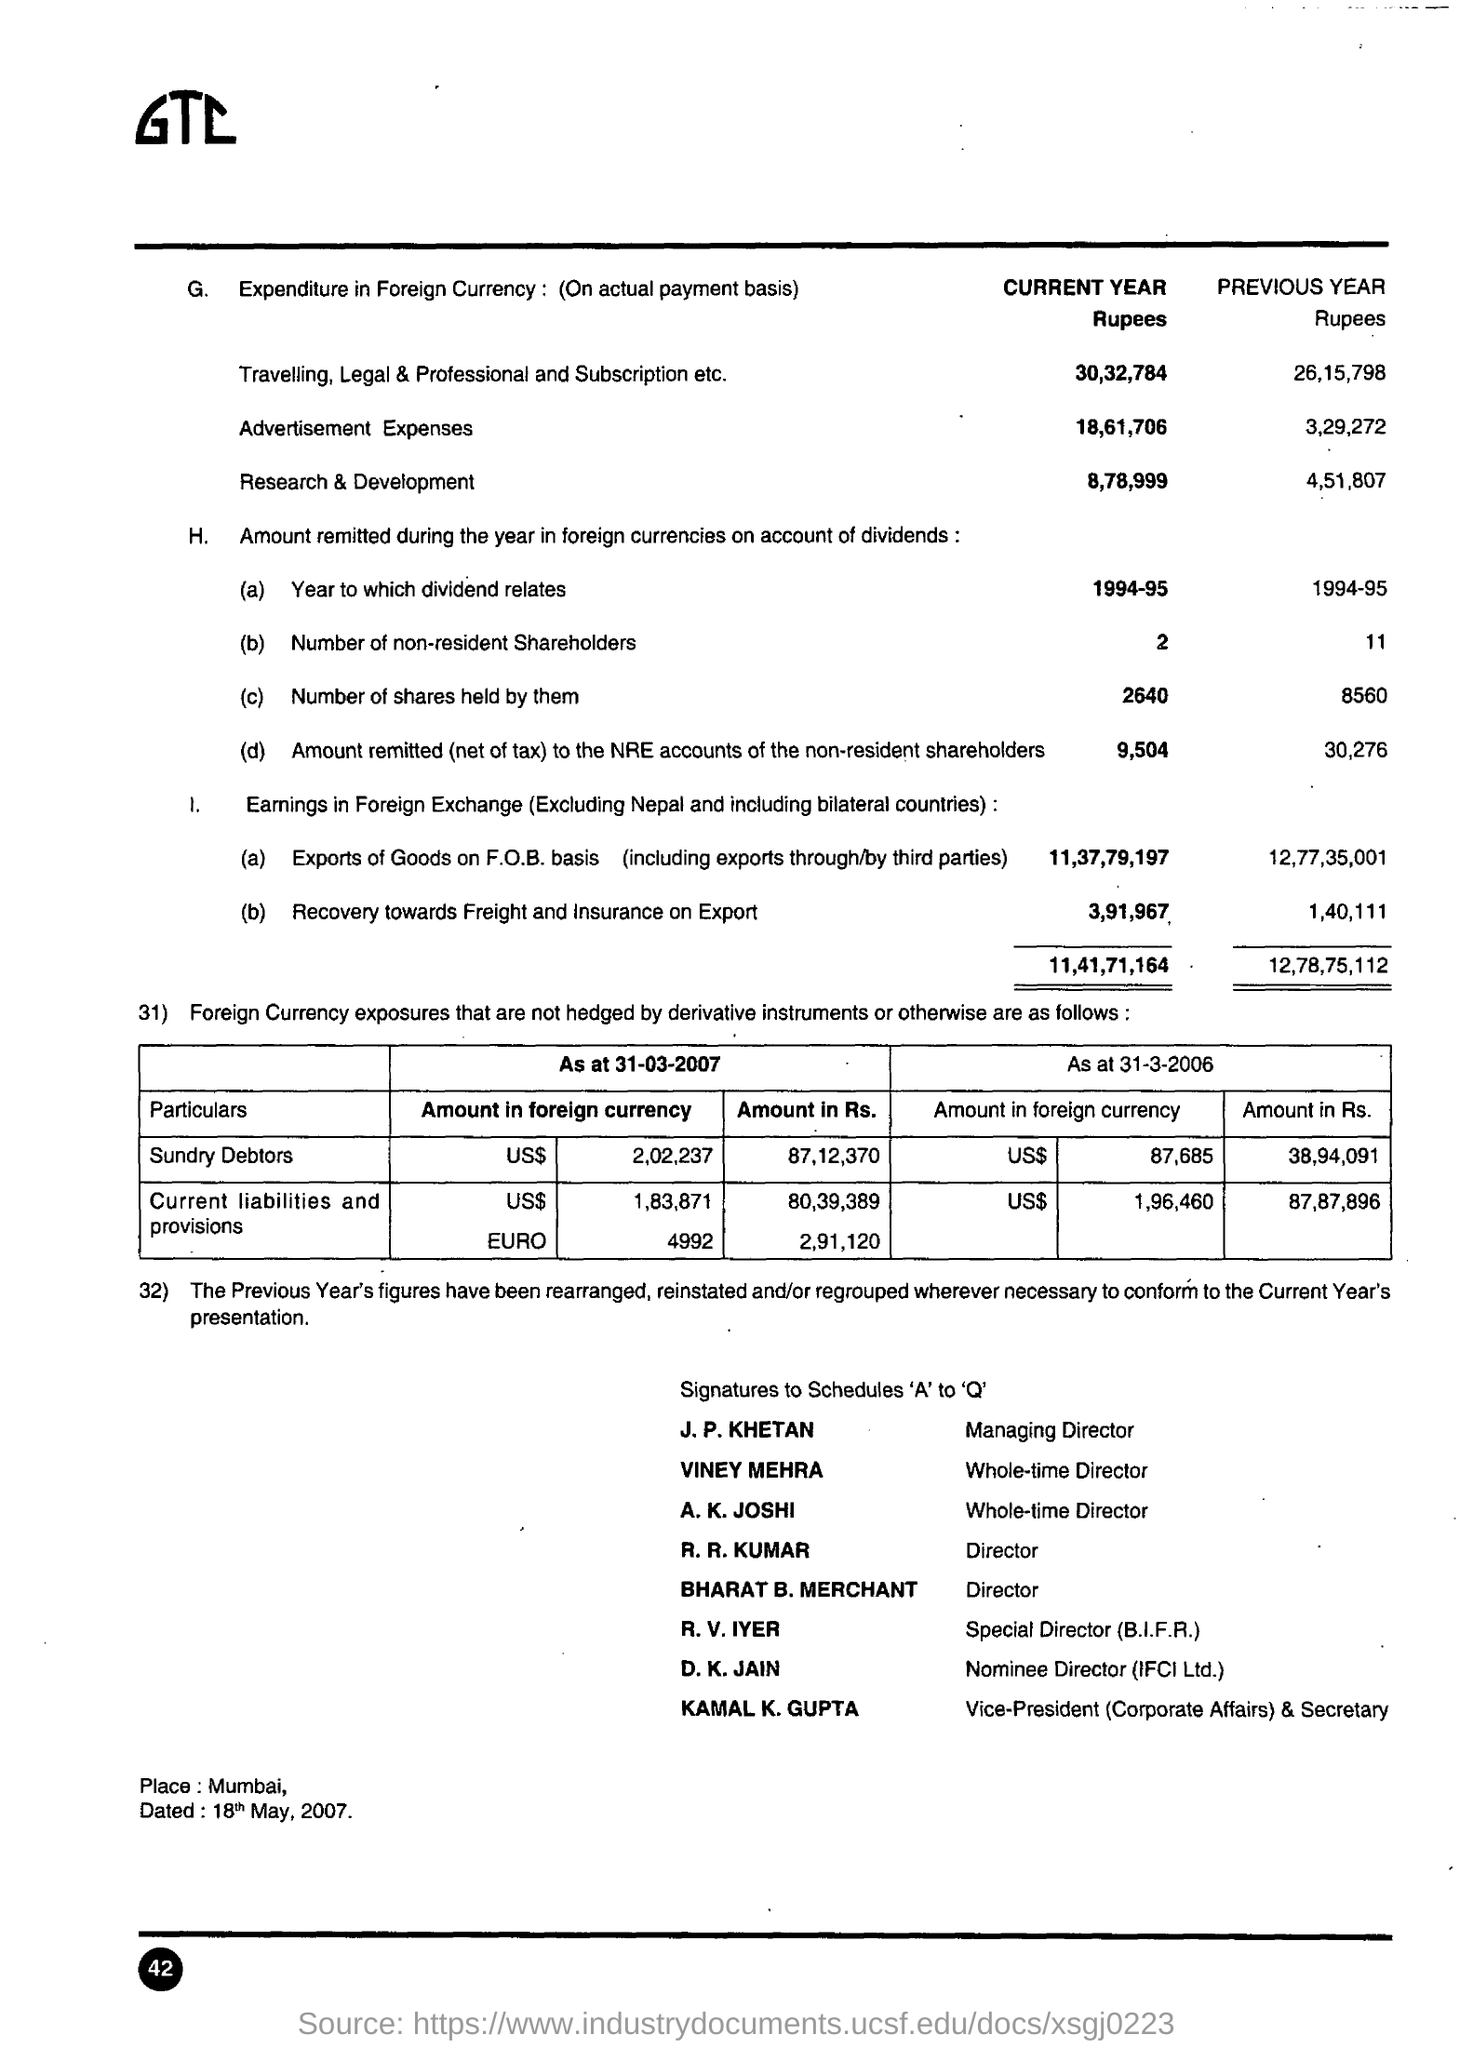How much Current year amount for Research & Development ?
Offer a terse response. 8,78,999. Who is the Managing Director ?
Provide a short and direct response. J. P. KHETAN. What is the Designation of R. R. Kumar ?
Offer a terse response. Director. What is the date mentioned in the bottom of the document ?
Ensure brevity in your answer.  18th may, 2007. Who is the Special Director ?
Give a very brief answer. R. v. iyer. Where is the Location ?
Keep it short and to the point. Mumbai. 